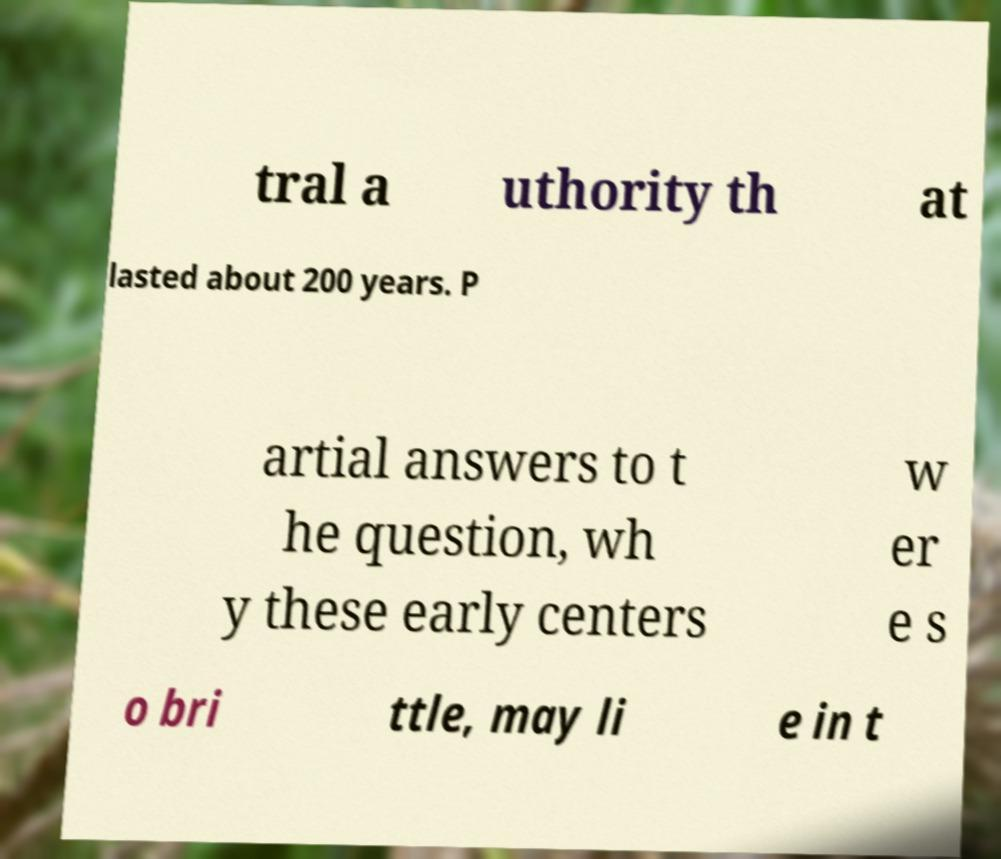What messages or text are displayed in this image? I need them in a readable, typed format. tral a uthority th at lasted about 200 years. P artial answers to t he question, wh y these early centers w er e s o bri ttle, may li e in t 